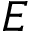Convert formula to latex. <formula><loc_0><loc_0><loc_500><loc_500>E</formula> 